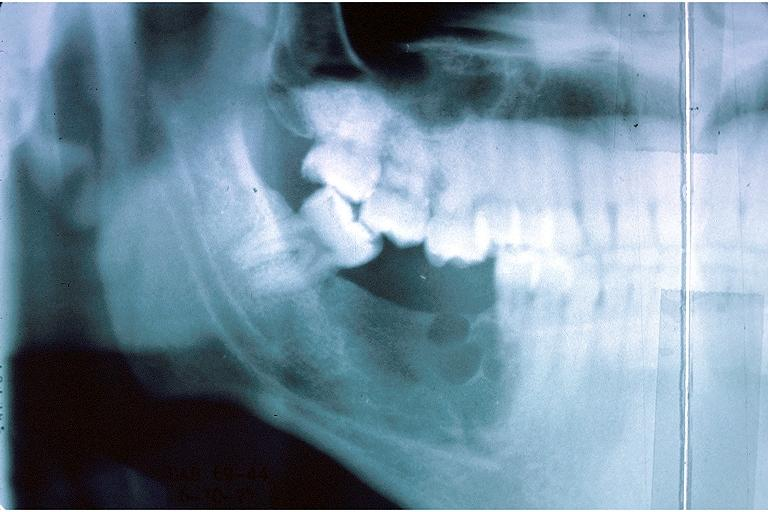what is present?
Answer the question using a single word or phrase. Oral 